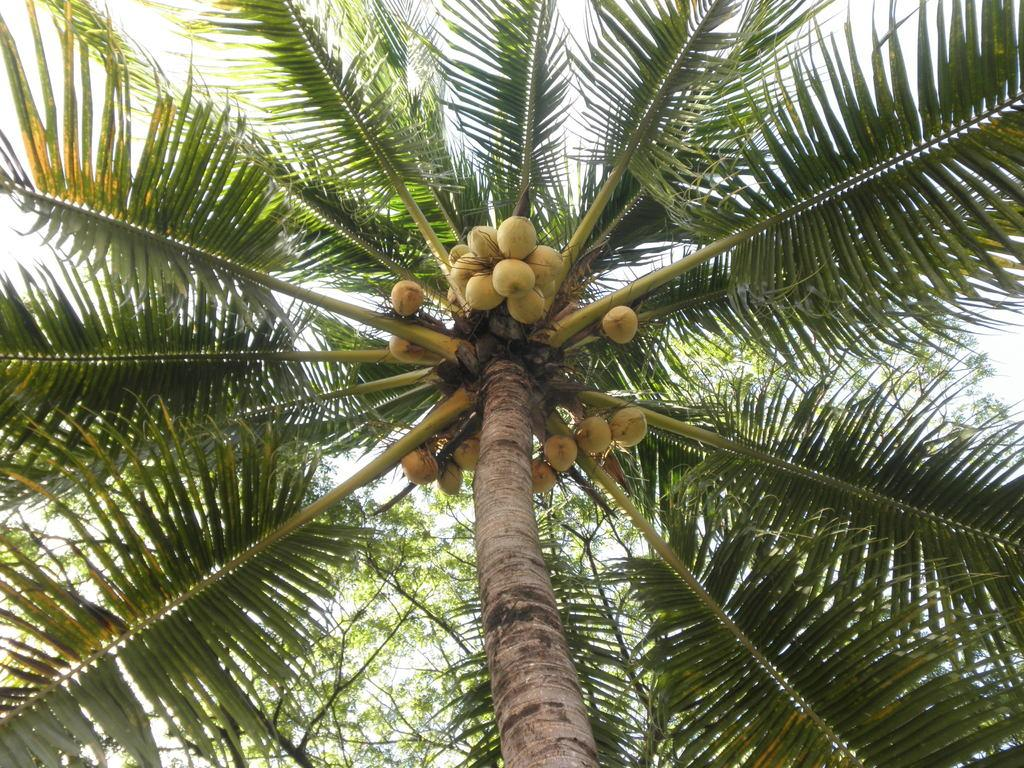What is the main feature in the center of the image? The center of the image contains the sky. What can be seen in the sky? Clouds are present in the sky. What type of vegetation is visible in the image? Trees are visible in the image. What type of fruit is present in the image? Coconuts are present in the image. What beginner's guide can be seen in the image? There is no beginner's guide present in the image. What type of connection is established between the trees and the sky in the image? There is no connection established between the trees and the sky in the image; they are separate elements. 